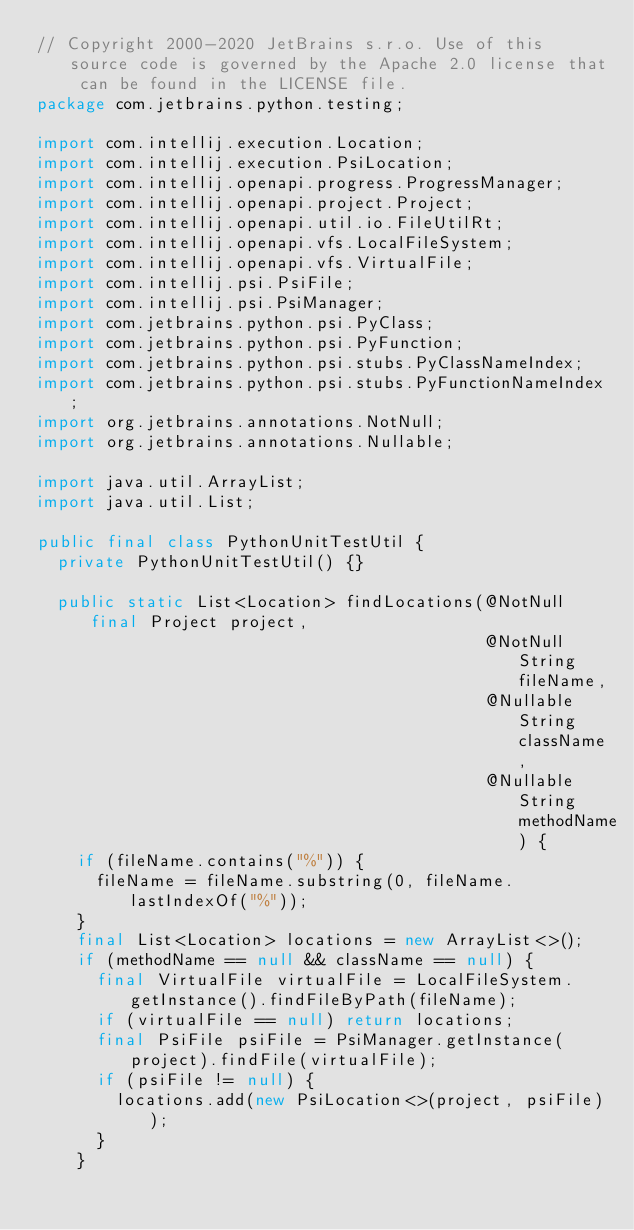Convert code to text. <code><loc_0><loc_0><loc_500><loc_500><_Java_>// Copyright 2000-2020 JetBrains s.r.o. Use of this source code is governed by the Apache 2.0 license that can be found in the LICENSE file.
package com.jetbrains.python.testing;

import com.intellij.execution.Location;
import com.intellij.execution.PsiLocation;
import com.intellij.openapi.progress.ProgressManager;
import com.intellij.openapi.project.Project;
import com.intellij.openapi.util.io.FileUtilRt;
import com.intellij.openapi.vfs.LocalFileSystem;
import com.intellij.openapi.vfs.VirtualFile;
import com.intellij.psi.PsiFile;
import com.intellij.psi.PsiManager;
import com.jetbrains.python.psi.PyClass;
import com.jetbrains.python.psi.PyFunction;
import com.jetbrains.python.psi.stubs.PyClassNameIndex;
import com.jetbrains.python.psi.stubs.PyFunctionNameIndex;
import org.jetbrains.annotations.NotNull;
import org.jetbrains.annotations.Nullable;

import java.util.ArrayList;
import java.util.List;

public final class PythonUnitTestUtil {
  private PythonUnitTestUtil() {}

  public static List<Location> findLocations(@NotNull final Project project,
                                             @NotNull String fileName,
                                             @Nullable String className,
                                             @Nullable String methodName) {
    if (fileName.contains("%")) {
      fileName = fileName.substring(0, fileName.lastIndexOf("%"));
    }
    final List<Location> locations = new ArrayList<>();
    if (methodName == null && className == null) {
      final VirtualFile virtualFile = LocalFileSystem.getInstance().findFileByPath(fileName);
      if (virtualFile == null) return locations;
      final PsiFile psiFile = PsiManager.getInstance(project).findFile(virtualFile);
      if (psiFile != null) {
        locations.add(new PsiLocation<>(project, psiFile));
      }
    }
</code> 